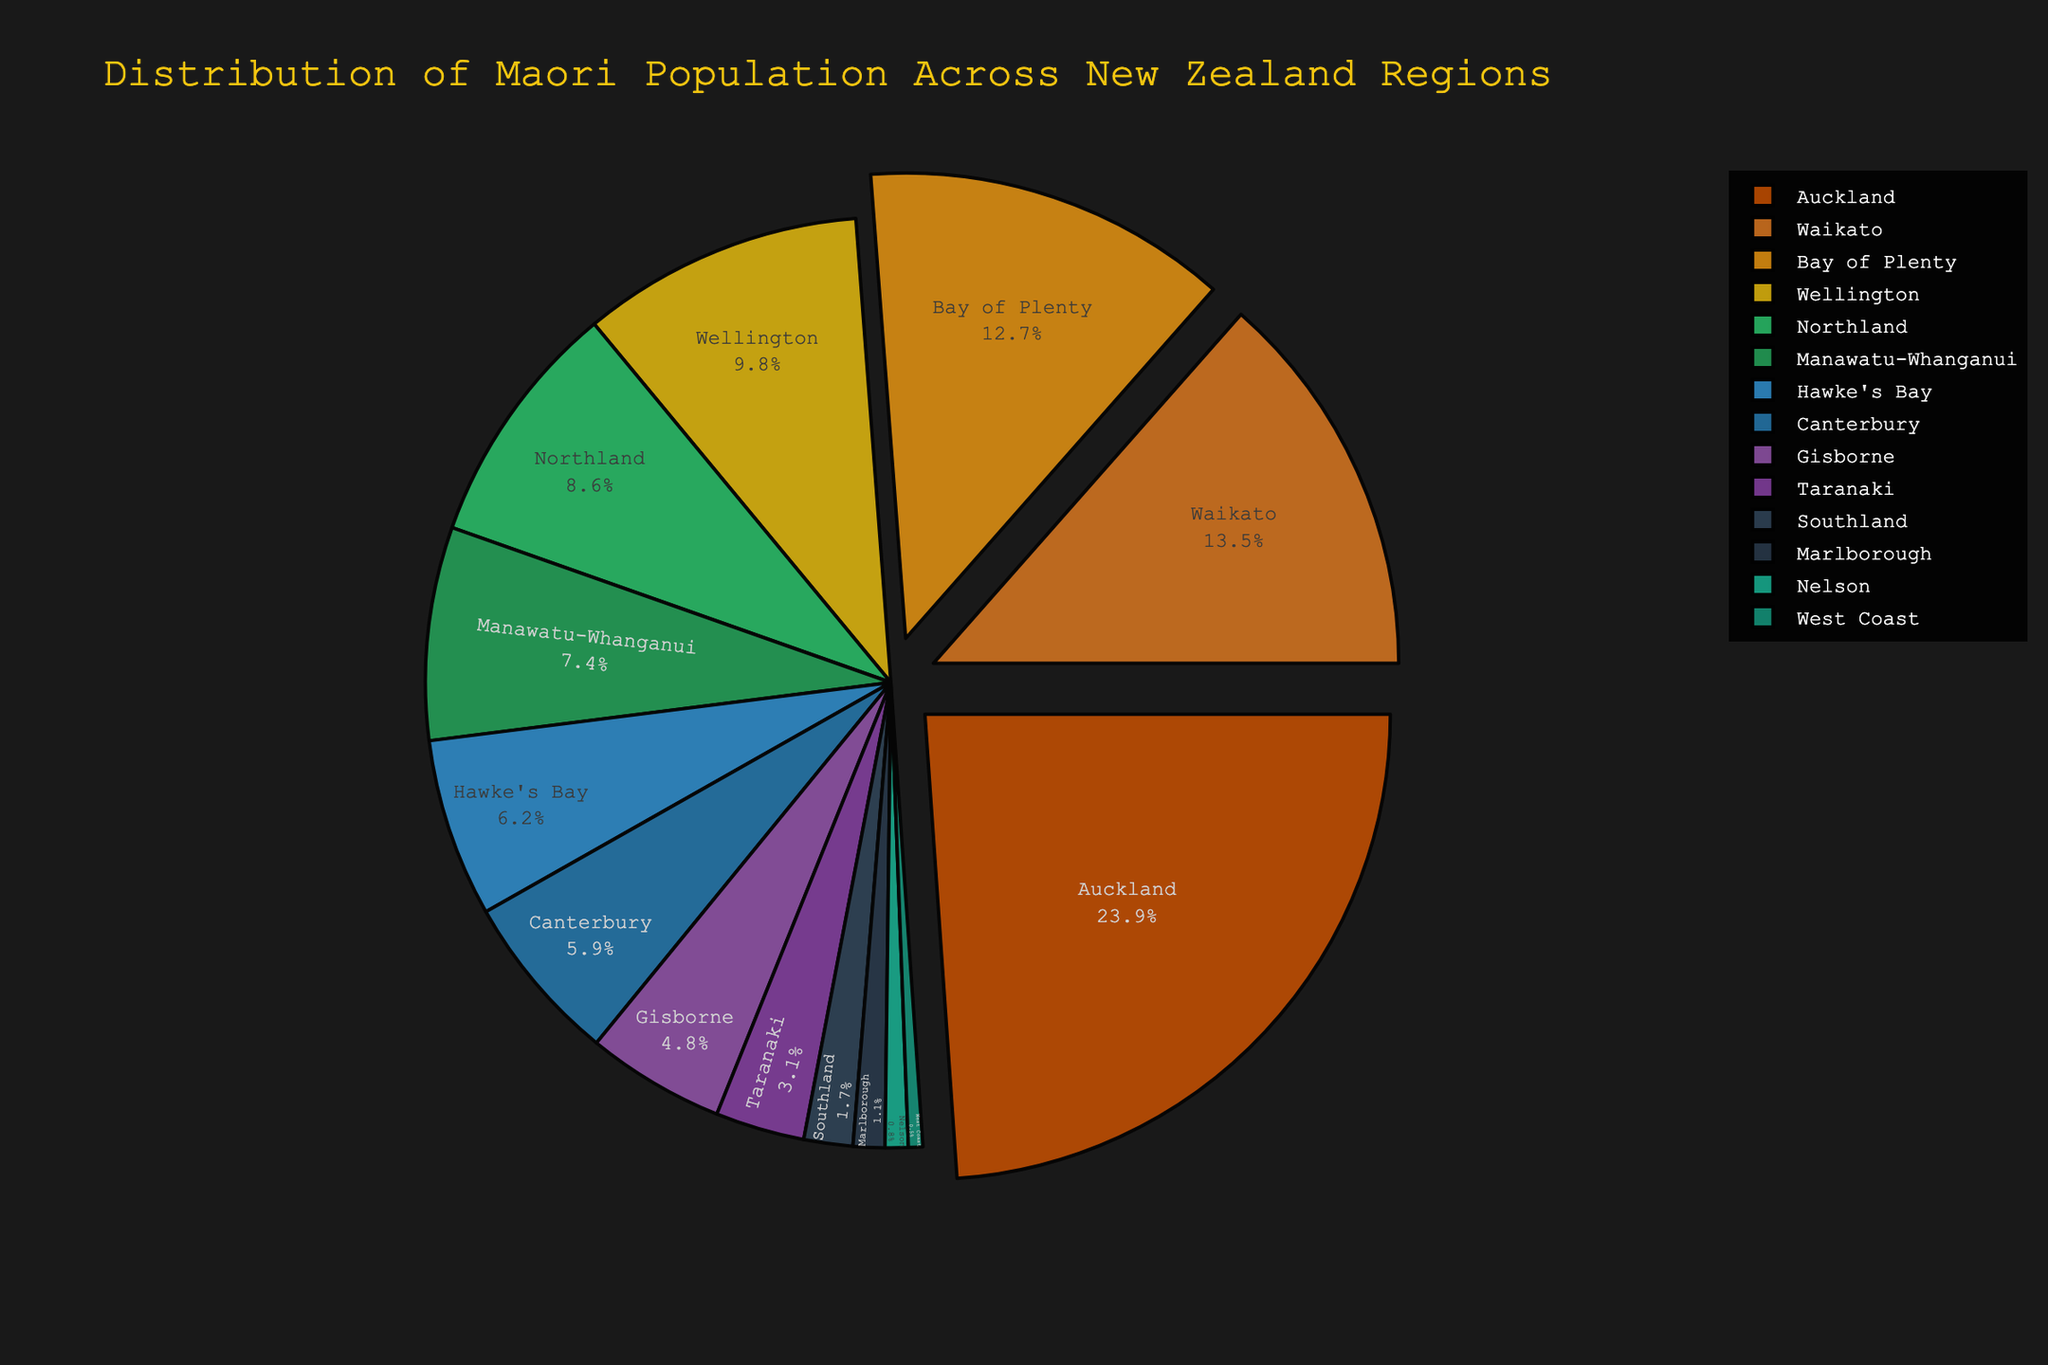What region has the highest percentage of the Maori population? Examine the pie chart for the largest section or wedge, which in this case, corresponds to Auckland with 23.9%.
Answer: Auckland Which two regions have a combined Maori population percentage greater than 20%? Look for regions whose combined percentage is greater than 20%. Waikato (13.5%) and Bay of Plenty (12.7%) give 26.2%.
Answer: Waikato and Bay of Plenty What is the total Maori population percentage in the Northland and Gisborne regions? Add the percentages for Northland (8.6%) and Gisborne (4.8%). The sum is 8.6 + 4.8 = 13.4%.
Answer: 13.4% Which region has approximately half the Maori population percentage of Auckland? Look for a region with around half of Auckland's percentage (23.9/2 ≈ 12%). Bay of Plenty with 12.7% is closest.
Answer: Bay of Plenty What is the difference in the Maori population percentage between Wellington and Canterbury? Subtract the percentage of Canterbury (5.9%) from Wellington (9.8%). The difference is 9.8 - 5.9 = 3.9%.
Answer: 3.9% Which regions have a Maori population percentage less than 5%? Identify the regions with percentages less than 5%. They are Gisborne (4.8%), Taranaki (3.1%), Southland (1.7%), Marlborough (1.1%), Nelson (0.8%), and West Coast (0.5%).
Answer: Gisborne, Taranaki, Southland, Marlborough, Nelson, and West Coast What is the combined Maori population percentage of the four smallest regions? Add the percentages for the smallest regions: Southland (1.7%), Marlborough (1.1%), Nelson (0.8%), and West Coast (0.5%). The sum is 1.7 + 1.1 + 0.8 + 0.5 = 4.1%.
Answer: 4.1% Which region with a Maori population percentage more than 10% but less than 15% seems visually the largest? Identify the regions within the 10-15% range: Waikato (13.5%) and Bay of Plenty (12.7%). Waikato (13.5%) visually seems larger.
Answer: Waikato How does the percentage of the Maori population in Auckland compare to the combined percentage of Southland, Marlborough, and Nelson? Compare Auckland's percentage (23.9%) to the sum of Southland (1.7%), Marlborough (1.1%), and Nelson (0.8%), which equals 1.7 + 1.1 + 0.8 = 3.6%. 23.9% is much greater.
Answer: Auckland's is much greater 